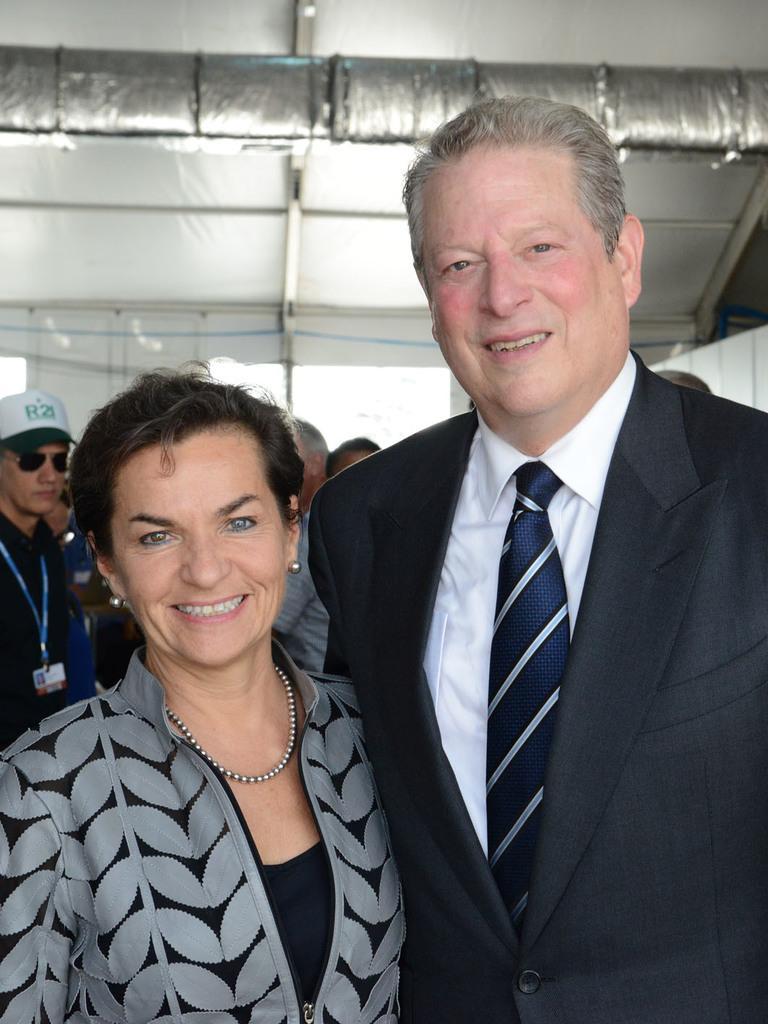In one or two sentences, can you explain what this image depicts? In the image there are two people standing and posing for the photo they are smiling and behind them on the left side there is a man he is wearing goggles, hat and id card. In the background there is a window. 